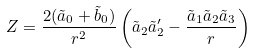Convert formula to latex. <formula><loc_0><loc_0><loc_500><loc_500>Z = \frac { 2 ( \tilde { a } _ { 0 } + \tilde { b } _ { 0 } ) } { r ^ { 2 } } \left ( \tilde { a } _ { 2 } \tilde { a } _ { 2 } ^ { \prime } - \frac { \tilde { a } _ { 1 } \tilde { a } _ { 2 } \tilde { a } _ { 3 } } { r } \right )</formula> 